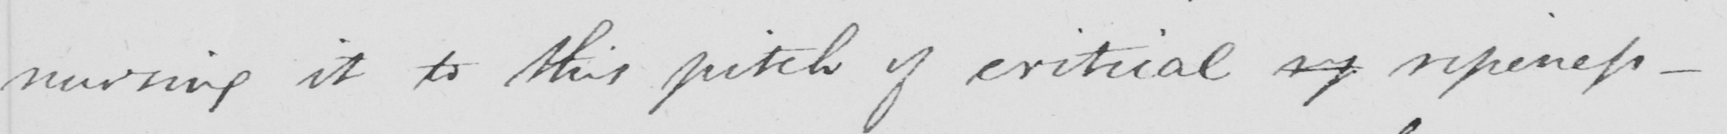Can you tell me what this handwritten text says? nursing it to this pitch of critical rp ripeness  _ 